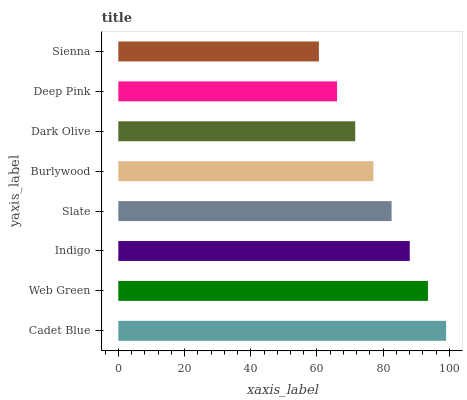Is Sienna the minimum?
Answer yes or no. Yes. Is Cadet Blue the maximum?
Answer yes or no. Yes. Is Web Green the minimum?
Answer yes or no. No. Is Web Green the maximum?
Answer yes or no. No. Is Cadet Blue greater than Web Green?
Answer yes or no. Yes. Is Web Green less than Cadet Blue?
Answer yes or no. Yes. Is Web Green greater than Cadet Blue?
Answer yes or no. No. Is Cadet Blue less than Web Green?
Answer yes or no. No. Is Slate the high median?
Answer yes or no. Yes. Is Burlywood the low median?
Answer yes or no. Yes. Is Indigo the high median?
Answer yes or no. No. Is Dark Olive the low median?
Answer yes or no. No. 